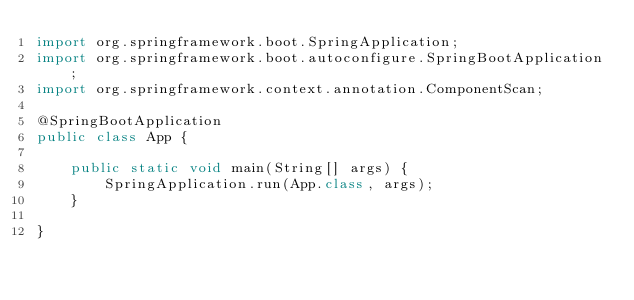<code> <loc_0><loc_0><loc_500><loc_500><_Java_>import org.springframework.boot.SpringApplication;
import org.springframework.boot.autoconfigure.SpringBootApplication;
import org.springframework.context.annotation.ComponentScan;

@SpringBootApplication
public class App {

    public static void main(String[] args) {
        SpringApplication.run(App.class, args);
    }

}
</code> 